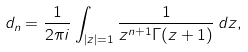Convert formula to latex. <formula><loc_0><loc_0><loc_500><loc_500>d _ { n } = \frac { 1 } { 2 \pi i } \int _ { | z | = 1 } \frac { 1 } { z ^ { n + 1 } \Gamma ( z + 1 ) } \, d z ,</formula> 